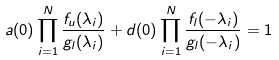Convert formula to latex. <formula><loc_0><loc_0><loc_500><loc_500>a ( 0 ) \prod _ { i = 1 } ^ { N } \frac { f _ { u } ( \lambda _ { i } ) } { g _ { l } ( \lambda _ { i } ) } + d ( 0 ) \prod _ { i = 1 } ^ { N } \frac { f _ { l } ( - \lambda _ { i } ) } { g _ { l } ( - \lambda _ { i } ) } = 1</formula> 